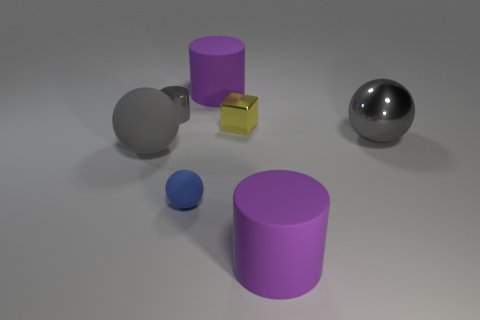What number of other objects are the same shape as the yellow object?
Offer a very short reply. 0. Are there more big gray matte things that are behind the gray metal ball than gray objects?
Provide a succinct answer. No. What is the shape of the purple thing behind the matte object in front of the rubber ball that is on the right side of the small gray metal cylinder?
Make the answer very short. Cylinder. Does the purple rubber thing that is in front of the blue sphere have the same shape as the purple thing that is behind the large gray rubber thing?
Keep it short and to the point. Yes. Are there any other things that are the same size as the gray rubber object?
Provide a succinct answer. Yes. What number of balls are either green metallic objects or gray metal things?
Your answer should be compact. 1. Is the material of the tiny cylinder the same as the cube?
Provide a succinct answer. Yes. What number of other objects are the same color as the tiny matte object?
Keep it short and to the point. 0. What shape is the large gray object that is left of the yellow thing?
Provide a succinct answer. Sphere. How many objects are tiny blue objects or large gray metallic objects?
Offer a terse response. 2. 